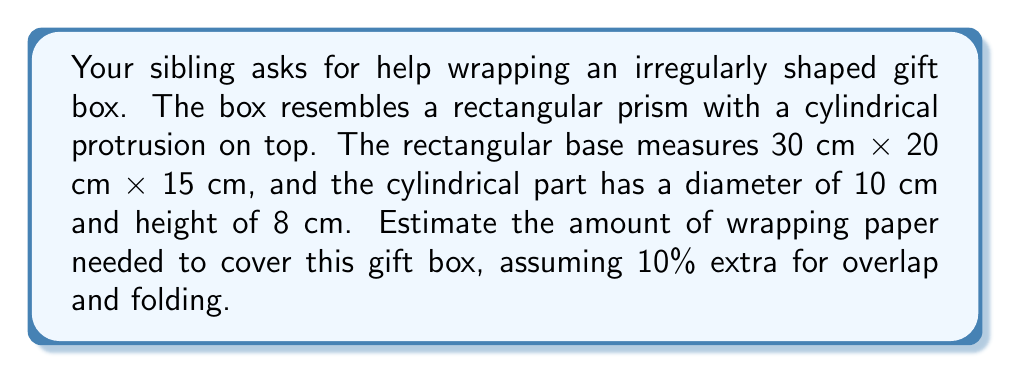Can you solve this math problem? Let's break this down step-by-step:

1. Calculate the surface area of the rectangular prism:
   $$A_{rect} = 2(lw + lh + wh)$$
   $$A_{rect} = 2((30 \times 20) + (30 \times 15) + (20 \times 15))$$
   $$A_{rect} = 2(600 + 450 + 300) = 2(1350) = 2700 \text{ cm}^2$$

2. Calculate the surface area of the cylindrical protrusion:
   - Lateral surface area: $$A_{lat} = \pi dh = \pi \times 10 \times 8 = 80\pi \text{ cm}^2$$
   - Top circular area: $$A_{top} = \pi r^2 = \pi \times 5^2 = 25\pi \text{ cm}^2$$

3. Sum up the total surface area:
   $$A_{total} = A_{rect} + A_{lat} + A_{top}$$
   $$A_{total} = 2700 + 80\pi + 25\pi = 2700 + 105\pi \text{ cm}^2$$

4. Convert $\pi$ to a decimal and calculate:
   $$A_{total} \approx 2700 + 105 \times 3.14159 \approx 3029.87 \text{ cm}^2$$

5. Add 10% for overlap and folding:
   $$A_{final} = A_{total} \times 1.1 \approx 3029.87 \times 1.1 \approx 3332.86 \text{ cm}^2$$

Therefore, you need approximately 3333 cm² of wrapping paper.
Answer: 3333 cm² 